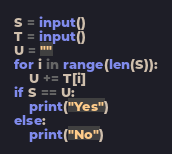<code> <loc_0><loc_0><loc_500><loc_500><_Python_>S = input()
T = input()
U = ""
for i in range(len(S)):
    U += T[i]
if S == U:
    print("Yes")
else:
    print("No")</code> 